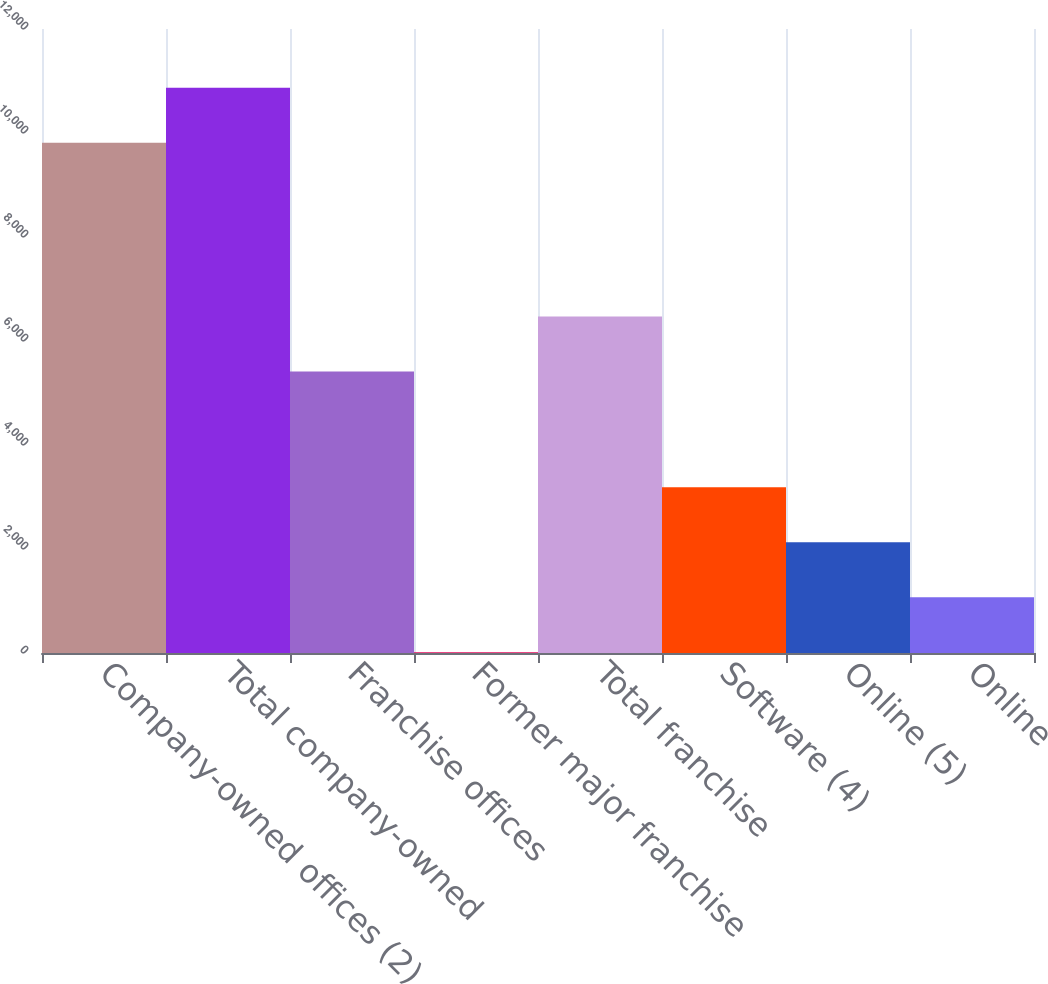Convert chart to OTSL. <chart><loc_0><loc_0><loc_500><loc_500><bar_chart><fcel>Company-owned offices (2)<fcel>Total company-owned<fcel>Franchise offices<fcel>Former major franchise<fcel>Total franchise<fcel>Software (4)<fcel>Online (5)<fcel>Online<nl><fcel>9811<fcel>10868<fcel>5413<fcel>16<fcel>6470<fcel>3187<fcel>2130<fcel>1073<nl></chart> 